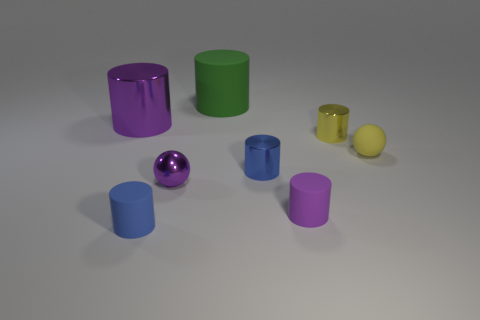Subtract all blue cylinders. How many cylinders are left? 4 Subtract all purple cylinders. How many cylinders are left? 4 Subtract all brown cylinders. Subtract all red balls. How many cylinders are left? 6 Add 2 tiny yellow shiny balls. How many objects exist? 10 Subtract all spheres. How many objects are left? 6 Subtract all small yellow rubber things. Subtract all tiny yellow shiny cylinders. How many objects are left? 6 Add 3 matte spheres. How many matte spheres are left? 4 Add 1 yellow metallic things. How many yellow metallic things exist? 2 Subtract 1 green cylinders. How many objects are left? 7 